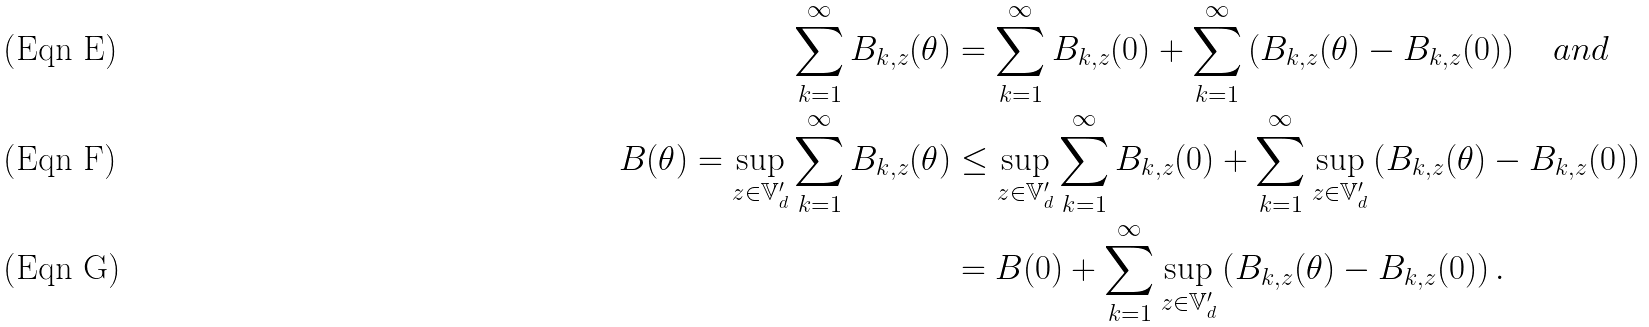<formula> <loc_0><loc_0><loc_500><loc_500>\sum _ { k = 1 } ^ { \infty } B _ { k , z } ( \theta ) & = \sum _ { k = 1 } ^ { \infty } B _ { k , z } ( 0 ) + \sum _ { k = 1 } ^ { \infty } \left ( B _ { k , z } ( \theta ) - B _ { k , z } ( 0 ) \right ) \quad a n d \\ B ( \theta ) = \sup _ { z \in \mathbb { V } _ { d } ^ { \prime } } \sum _ { k = 1 } ^ { \infty } B _ { k , z } ( \theta ) & \leq \sup _ { z \in \mathbb { V } _ { d } ^ { \prime } } \sum _ { k = 1 } ^ { \infty } B _ { k , z } ( 0 ) + \sum _ { k = 1 } ^ { \infty } \sup _ { z \in \mathbb { V } _ { d } ^ { \prime } } \left ( B _ { k , z } ( \theta ) - B _ { k , z } ( 0 ) \right ) \\ & = B ( 0 ) + \sum _ { k = 1 } ^ { \infty } \sup _ { z \in \mathbb { V } _ { d } ^ { \prime } } \left ( B _ { k , z } ( \theta ) - B _ { k , z } ( 0 ) \right ) .</formula> 